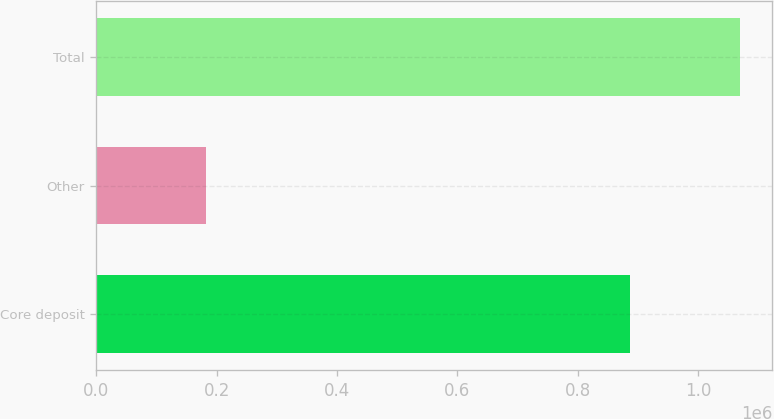<chart> <loc_0><loc_0><loc_500><loc_500><bar_chart><fcel>Core deposit<fcel>Other<fcel>Total<nl><fcel>887459<fcel>182568<fcel>1.07003e+06<nl></chart> 